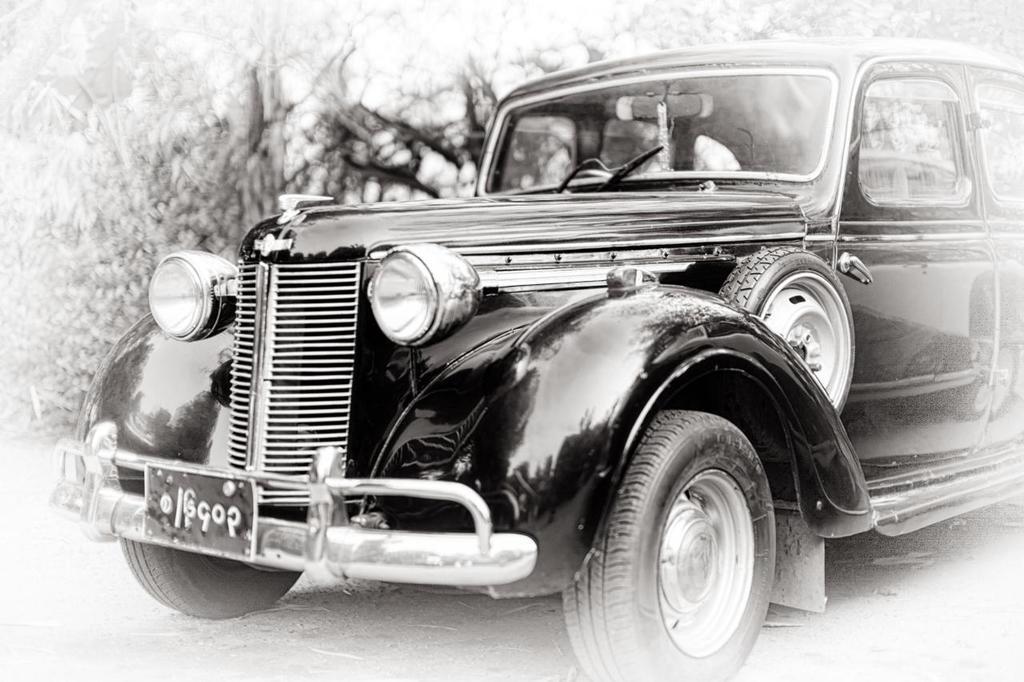In one or two sentences, can you explain what this image depicts? Here there is car. 